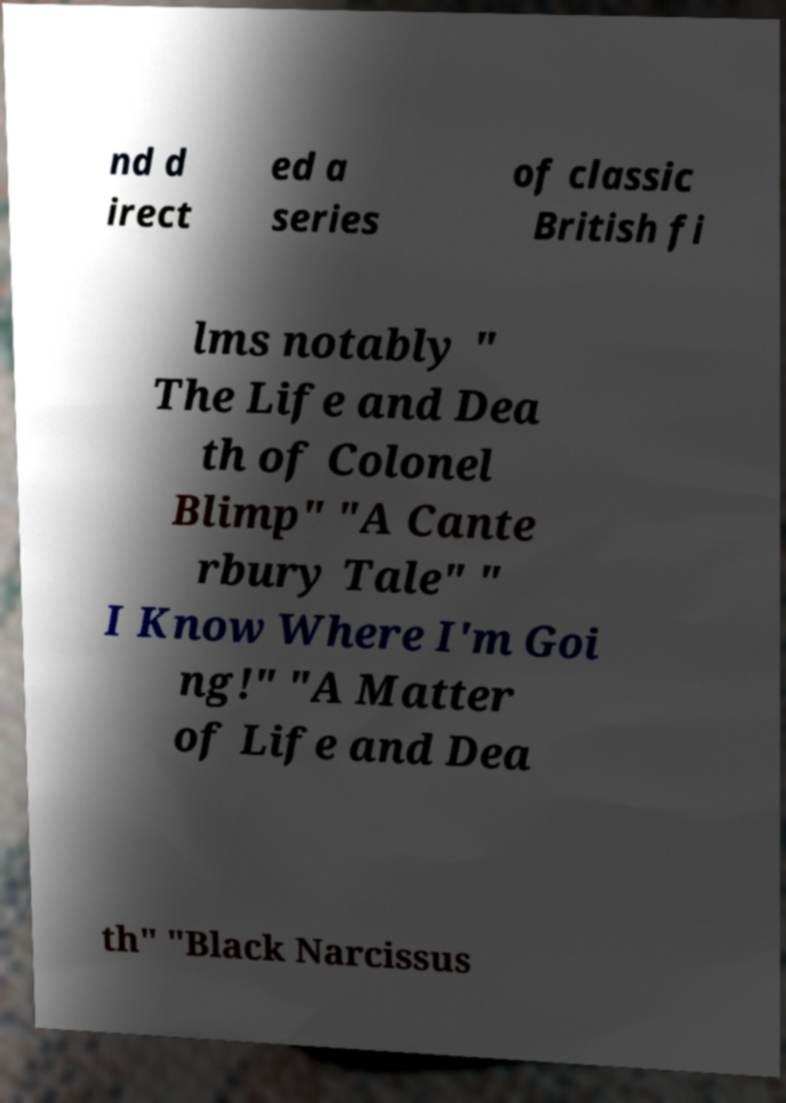Could you extract and type out the text from this image? nd d irect ed a series of classic British fi lms notably " The Life and Dea th of Colonel Blimp" "A Cante rbury Tale" " I Know Where I'm Goi ng!" "A Matter of Life and Dea th" "Black Narcissus 